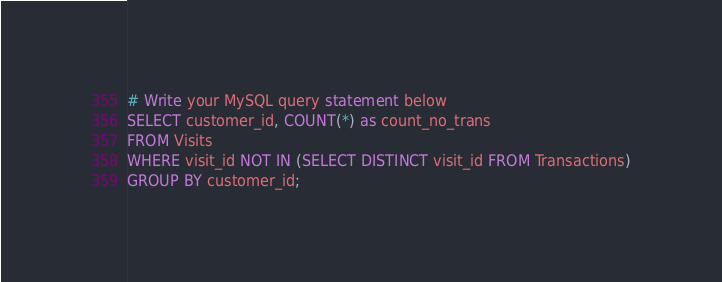<code> <loc_0><loc_0><loc_500><loc_500><_SQL_># Write your MySQL query statement below
SELECT customer_id, COUNT(*) as count_no_trans
FROM Visits
WHERE visit_id NOT IN (SELECT DISTINCT visit_id FROM Transactions)
GROUP BY customer_id;
</code> 